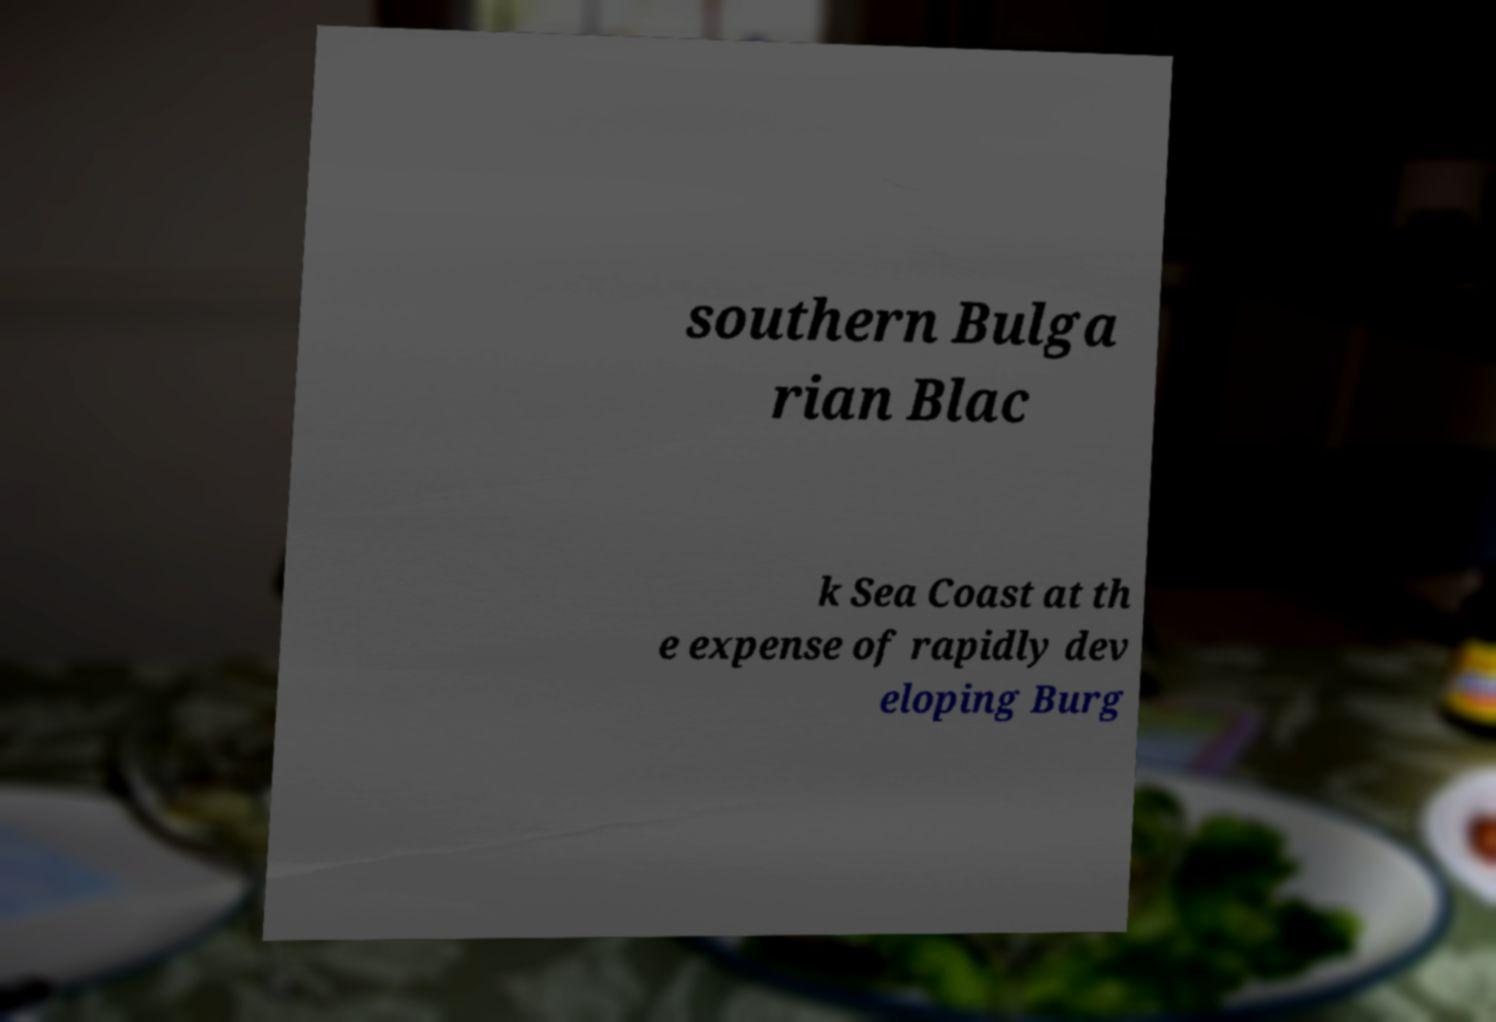Please read and relay the text visible in this image. What does it say? southern Bulga rian Blac k Sea Coast at th e expense of rapidly dev eloping Burg 